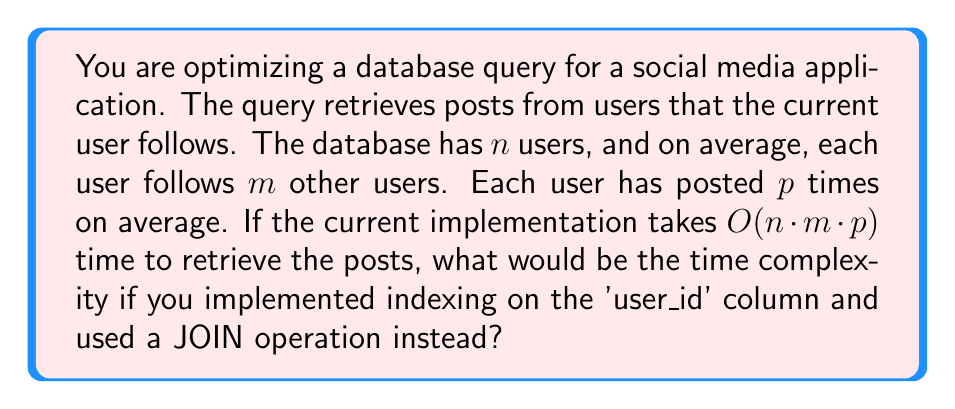Help me with this question. Let's break this down step-by-step:

1) The current implementation likely involves:
   - Fetching all users the current user follows: $O(m)$
   - For each of these users, fetching all their posts: $O(m \cdot p)$
   - Repeating this for all users: $O(n \cdot m \cdot p)$

2) By implementing indexing on the 'user_id' column:
   - Fetching a specific user's data becomes $O(\log n)$ instead of $O(n)$
   
3) Using a JOIN operation:
   - We can fetch all required data in a single query
   - The JOIN operation itself is typically $O(n \log n)$ for indexed columns

4) The new query would involve:
   - Joining the 'users' table with the 'follows' table: $O(n \log n)$
   - Then joining the result with the 'posts' table: $O((n+m\cdot p) \log (n+m\cdot p))$

5) The dominant term in this expression is $O((n+m\cdot p) \log (n+m\cdot p))$

6) Since $m$ and $p$ are typically much smaller than $n$ in large social networks, we can simplify this to $O(n \log n)$

This is a significant improvement over the original $O(n \cdot m \cdot p)$ time complexity.
Answer: $O(n \log n)$ 